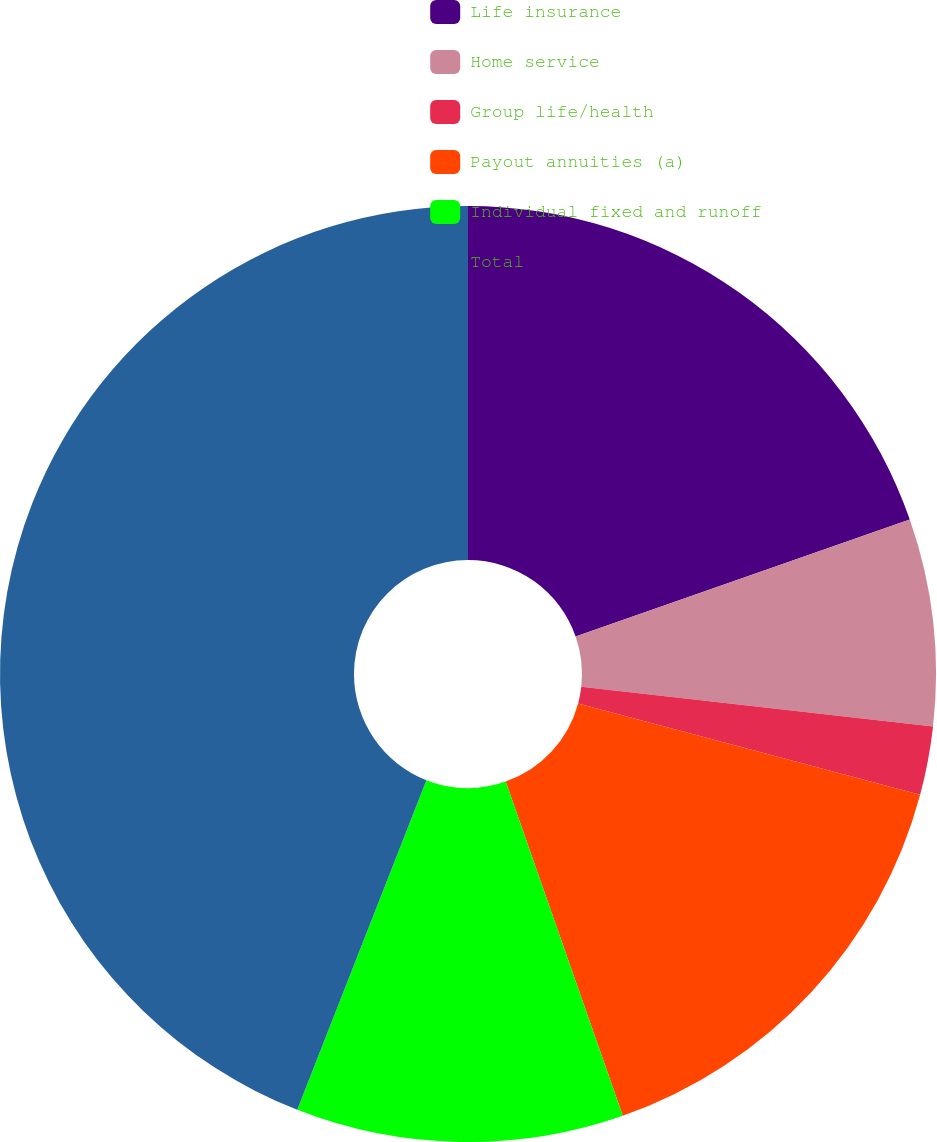Convert chart. <chart><loc_0><loc_0><loc_500><loc_500><pie_chart><fcel>Life insurance<fcel>Home service<fcel>Group life/health<fcel>Payout annuities (a)<fcel>Individual fixed and runoff<fcel>Total<nl><fcel>19.65%<fcel>7.14%<fcel>2.37%<fcel>15.48%<fcel>11.31%<fcel>44.06%<nl></chart> 